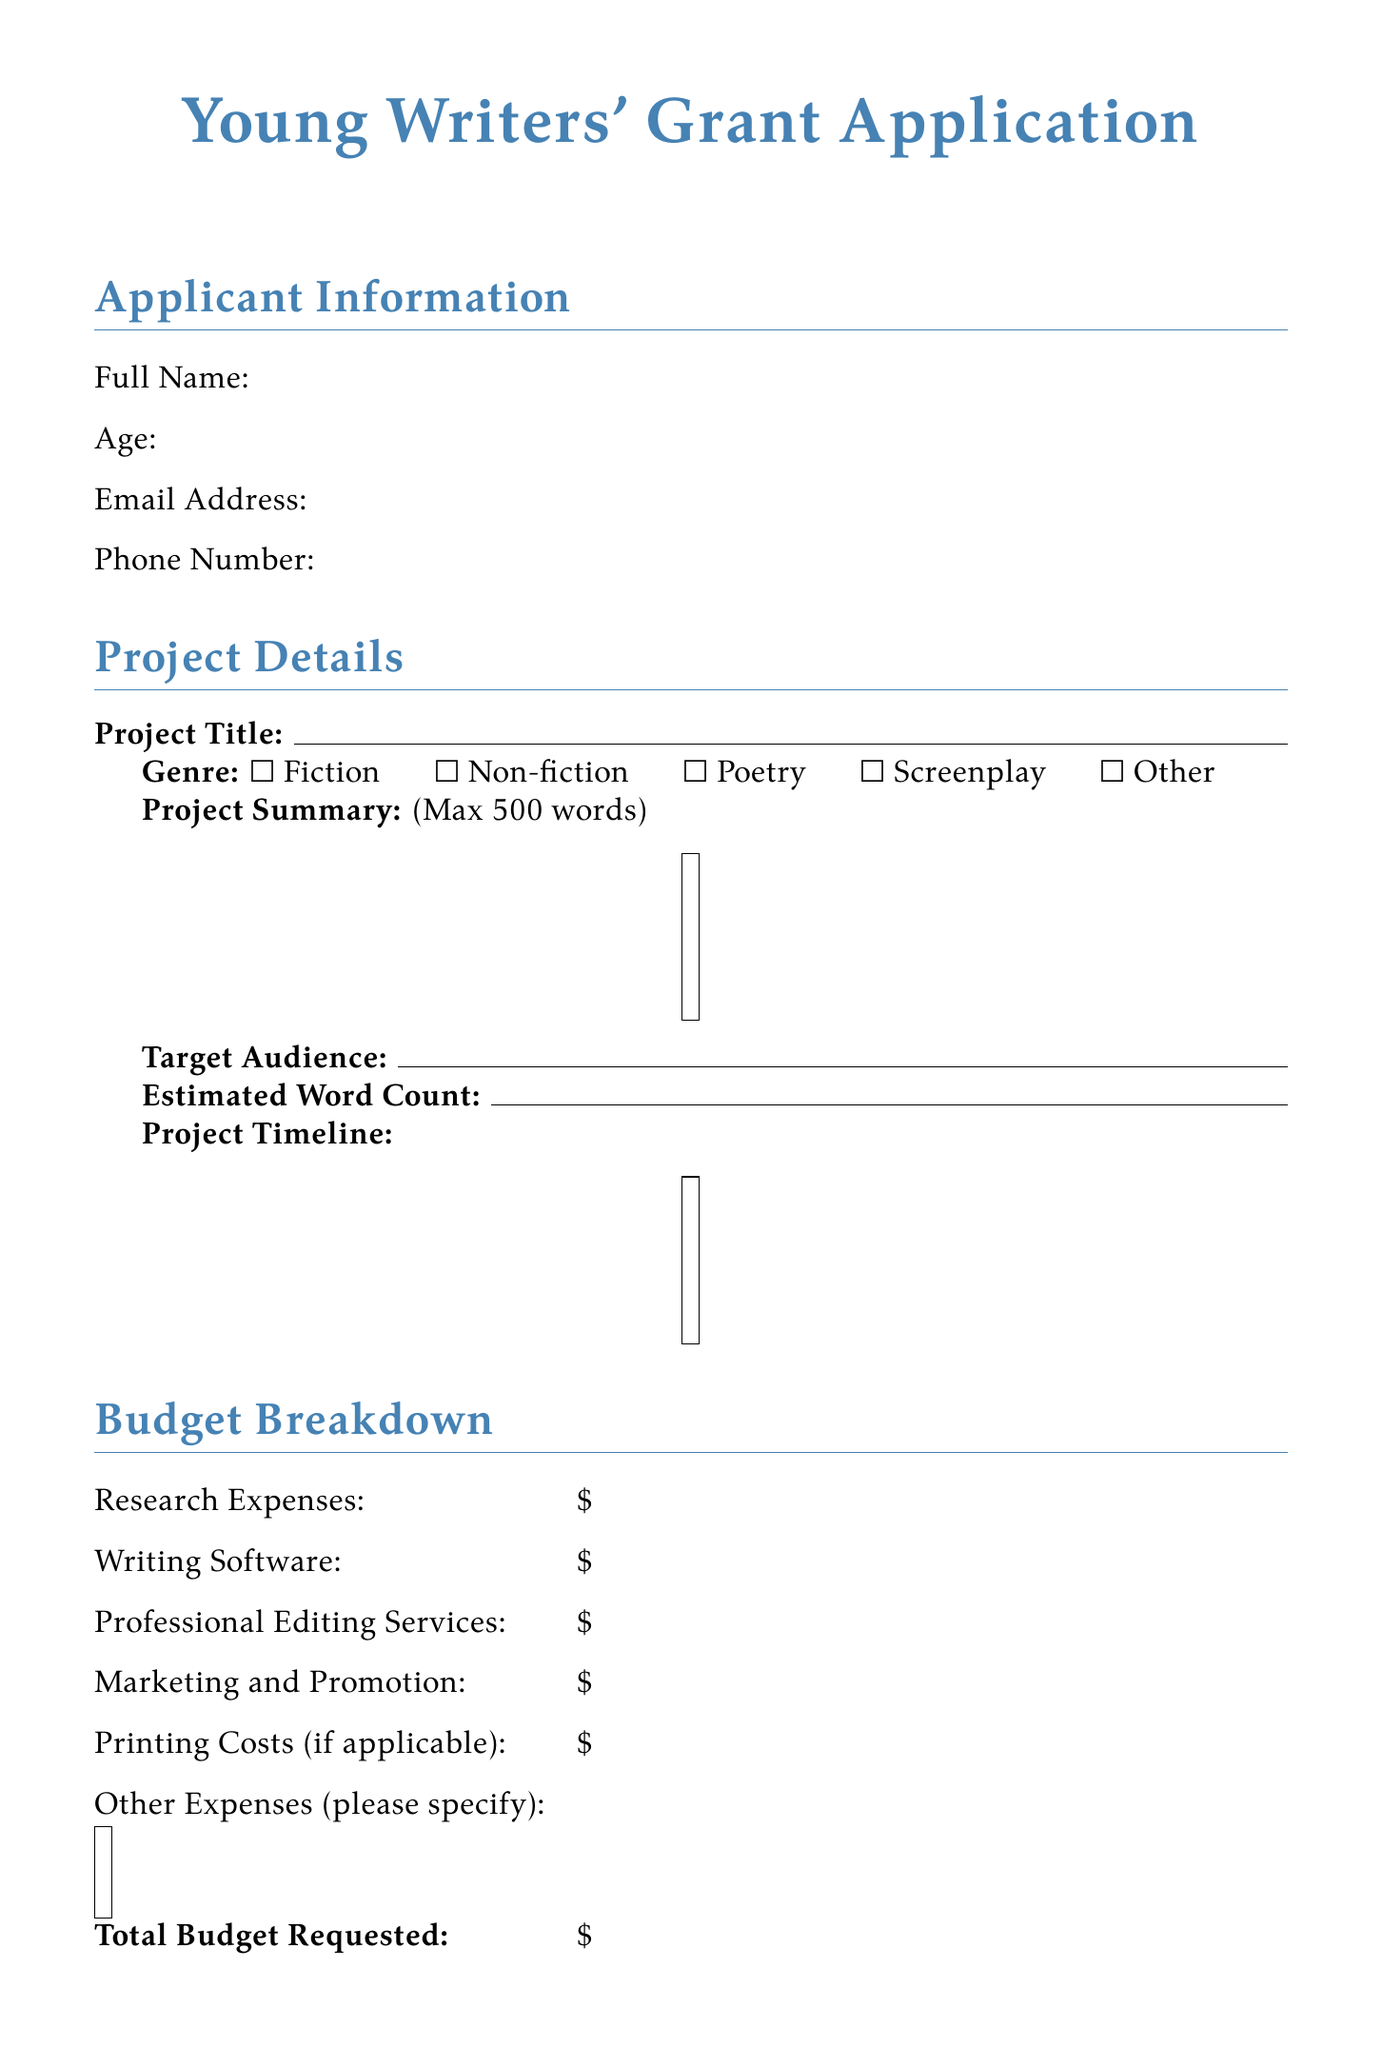What is the title of the grant application? The title is explicitly stated at the top of the document.
Answer: Young Writers' Grant Application What is the maximum length for the project summary? This information is provided under the project details section, indicating a limit.
Answer: 500 words What are the genres you can select for the project? The options for genre selection are listed in the project details section of the document.
Answer: Fiction, Non-fiction, Poetry, Screenplay, Other How many questions are asked in the impact statement section? The document provides the specific questions to be answered in this section.
Answer: Three What is the total budget requested? This is the final entry in the budget breakdown section where financial information is summarized.
Answer: \$ What is the maximum number of pages allowed for the writing sample? This detail is specified in the additional materials section.
Answer: 10 pages What must applicants check to confirm accuracy of information? This is a requirement outlined in the declaration section of the document.
Answer: The checkbox confirming accuracy of information How long may the grant review process take? This timeframe is mentioned in the submission guidelines of the document.
Answer: 8 weeks 